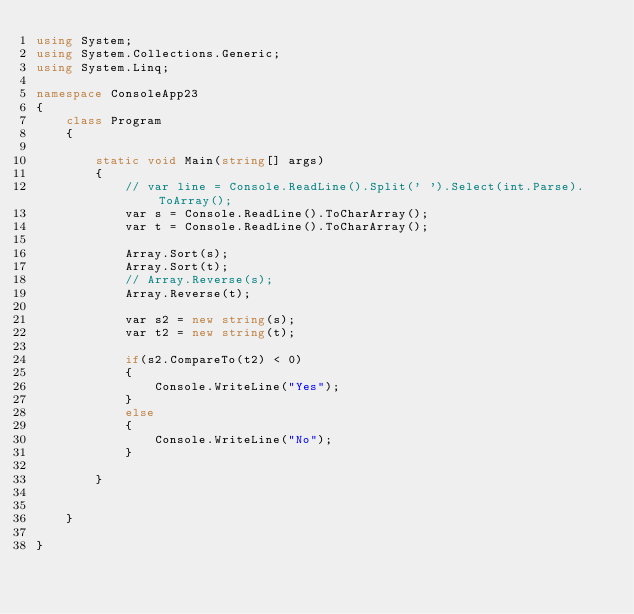<code> <loc_0><loc_0><loc_500><loc_500><_C#_>using System;
using System.Collections.Generic;
using System.Linq;

namespace ConsoleApp23
{
    class Program
    {

        static void Main(string[] args)
        {
            // var line = Console.ReadLine().Split(' ').Select(int.Parse).ToArray();
            var s = Console.ReadLine().ToCharArray();
            var t = Console.ReadLine().ToCharArray();

            Array.Sort(s);
            Array.Sort(t);
            // Array.Reverse(s);
            Array.Reverse(t);

            var s2 = new string(s);
            var t2 = new string(t);

            if(s2.CompareTo(t2) < 0)
            {
                Console.WriteLine("Yes");
            }
            else
            {
                Console.WriteLine("No");
            }

        }


    }

}
</code> 